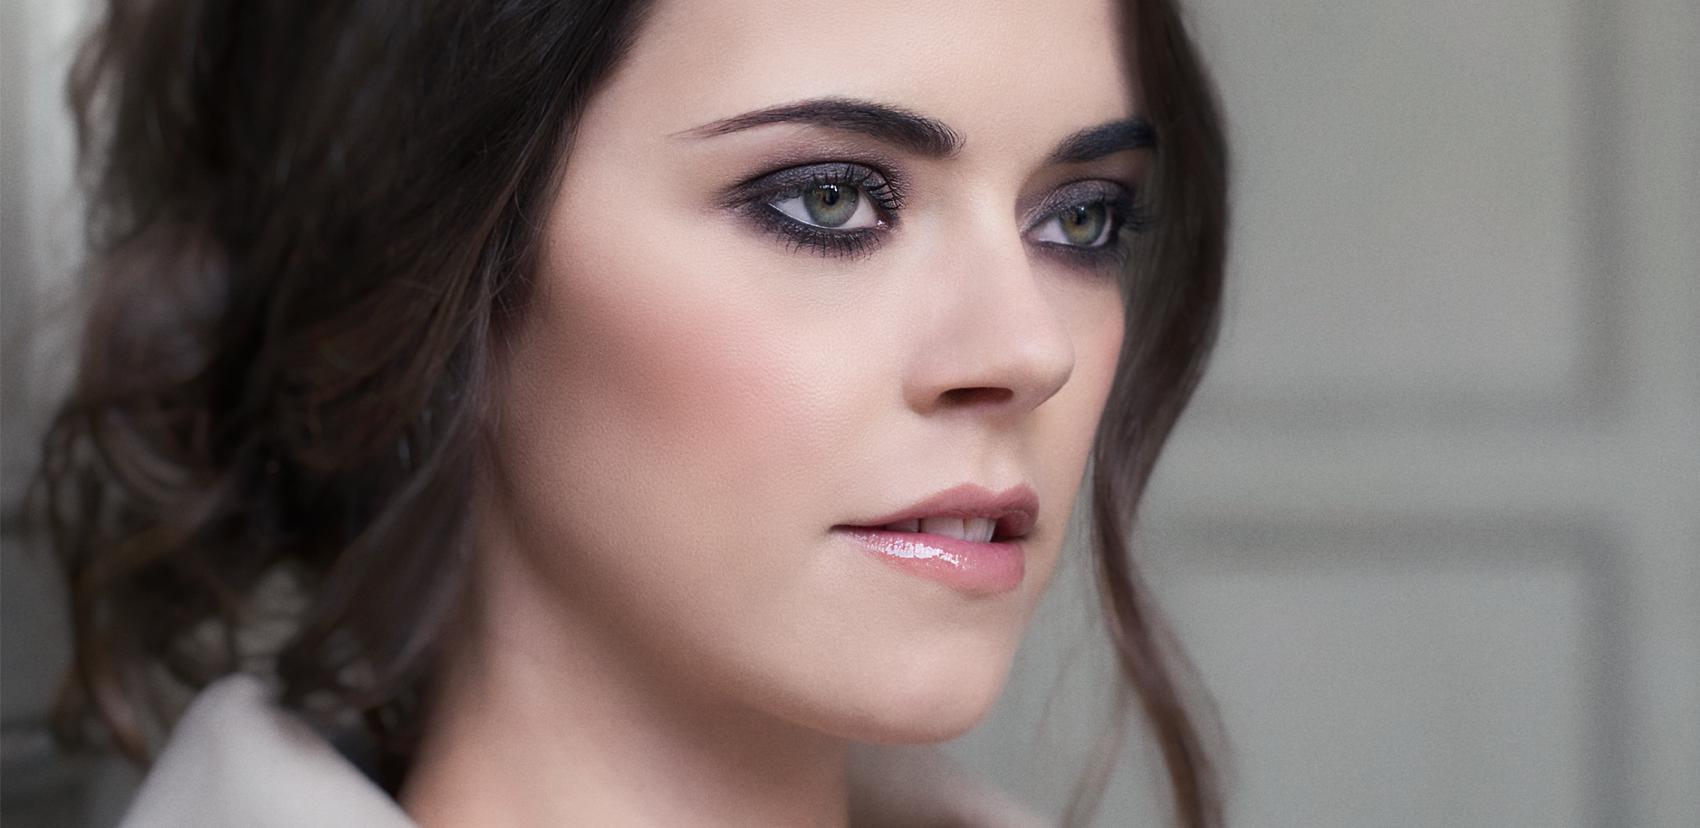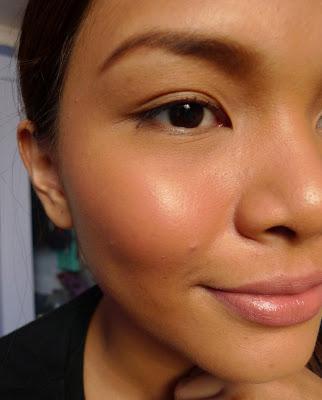The first image is the image on the left, the second image is the image on the right. For the images shown, is this caption "There is a lady looking directly at the camera." true? Answer yes or no. No. 